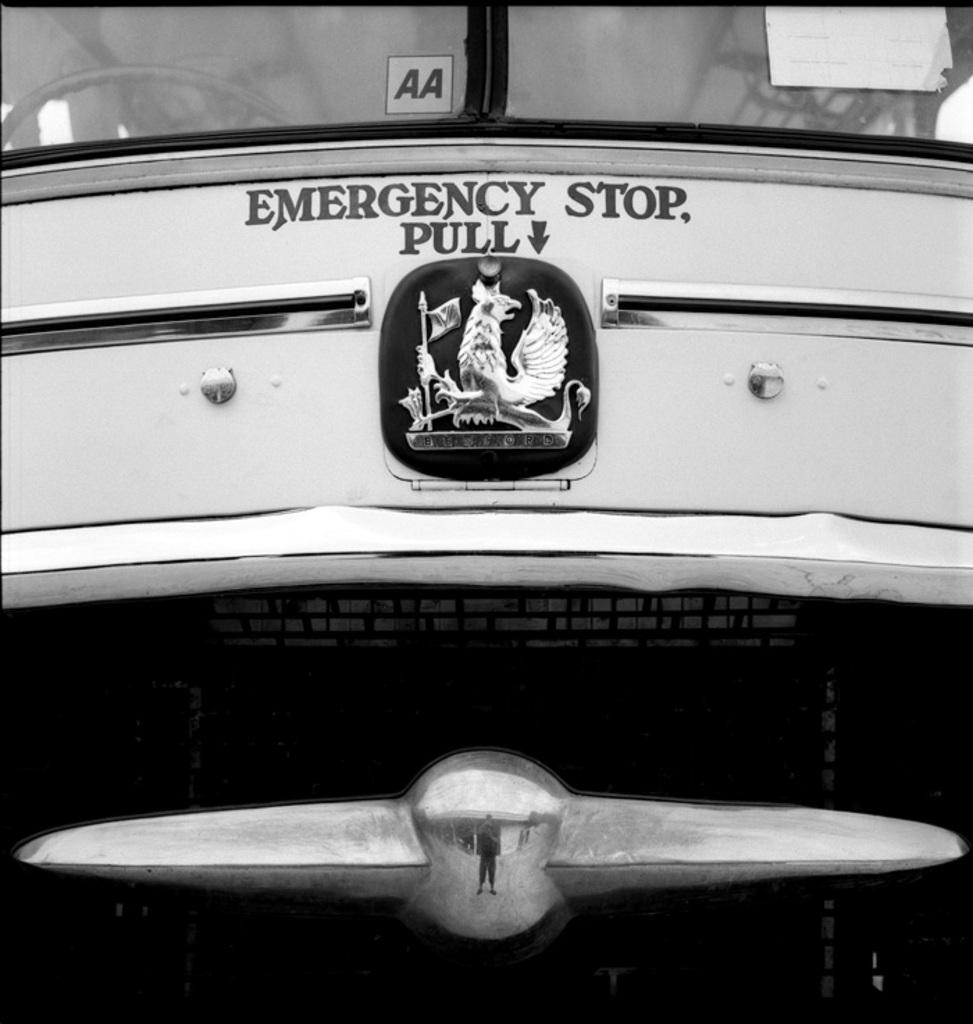What happens if you pull?
Offer a terse response. Emergency stop. What does the sticker on the window say?
Your answer should be very brief. Aa. 